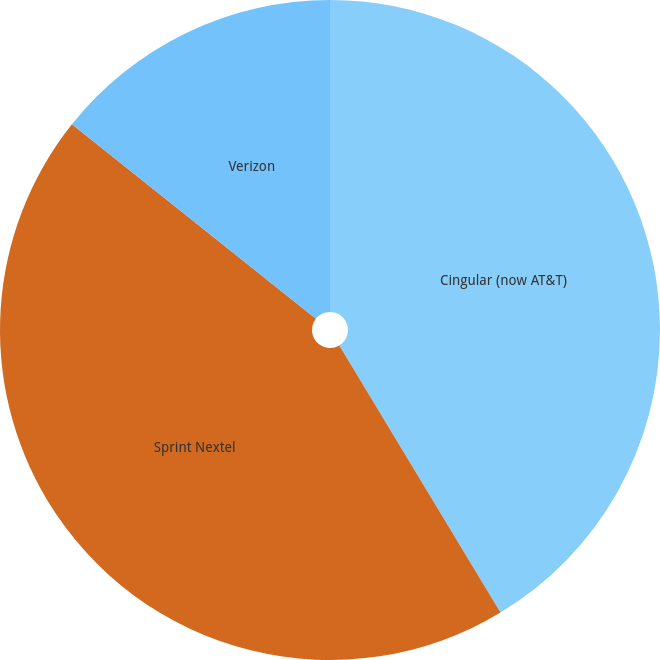Convert chart. <chart><loc_0><loc_0><loc_500><loc_500><pie_chart><fcel>Cingular (now AT&T)<fcel>Sprint Nextel<fcel>Verizon<nl><fcel>41.36%<fcel>44.35%<fcel>14.29%<nl></chart> 